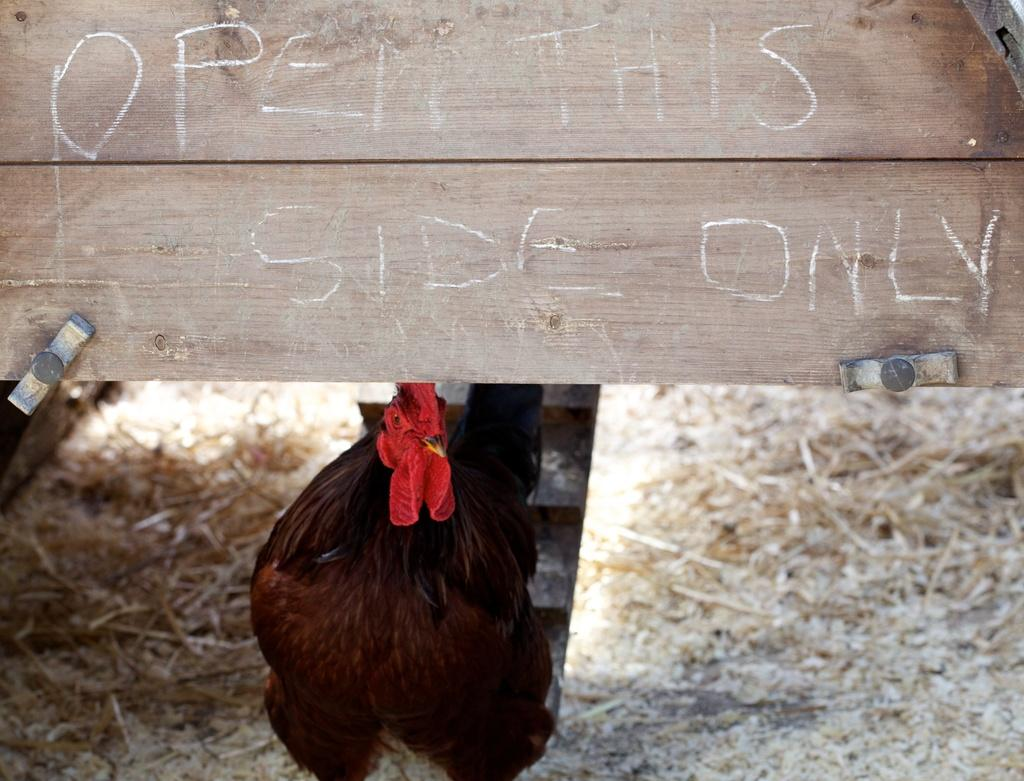What is the main subject in the center of the image? There is a bird in the center of the image. What is placed on top of the bird? There is a wooden block on top of the bird. What can be seen on the wooden block? There is text written on the wooden block. What type of ground is visible in the image? Dry grass is present on the ground in the image. Can you see a jar of water near the bird in the image? There is no jar of water present in the image. Is there a person interacting with the bird in the image? There is no person visible in the image. 